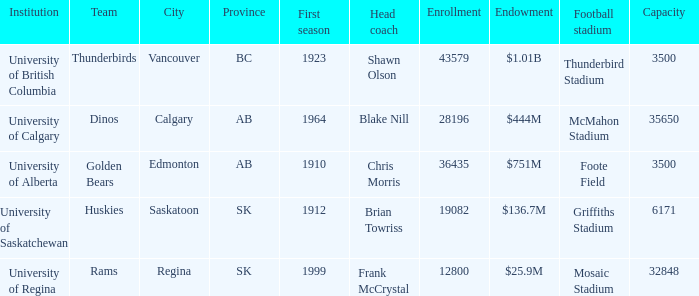How many contributions does mosaic stadium have? 1.0. Would you be able to parse every entry in this table? {'header': ['Institution', 'Team', 'City', 'Province', 'First season', 'Head coach', 'Enrollment', 'Endowment', 'Football stadium', 'Capacity'], 'rows': [['University of British Columbia', 'Thunderbirds', 'Vancouver', 'BC', '1923', 'Shawn Olson', '43579', '$1.01B', 'Thunderbird Stadium', '3500'], ['University of Calgary', 'Dinos', 'Calgary', 'AB', '1964', 'Blake Nill', '28196', '$444M', 'McMahon Stadium', '35650'], ['University of Alberta', 'Golden Bears', 'Edmonton', 'AB', '1910', 'Chris Morris', '36435', '$751M', 'Foote Field', '3500'], ['University of Saskatchewan', 'Huskies', 'Saskatoon', 'SK', '1912', 'Brian Towriss', '19082', '$136.7M', 'Griffiths Stadium', '6171'], ['University of Regina', 'Rams', 'Regina', 'SK', '1999', 'Frank McCrystal', '12800', '$25.9M', 'Mosaic Stadium', '32848']]} 